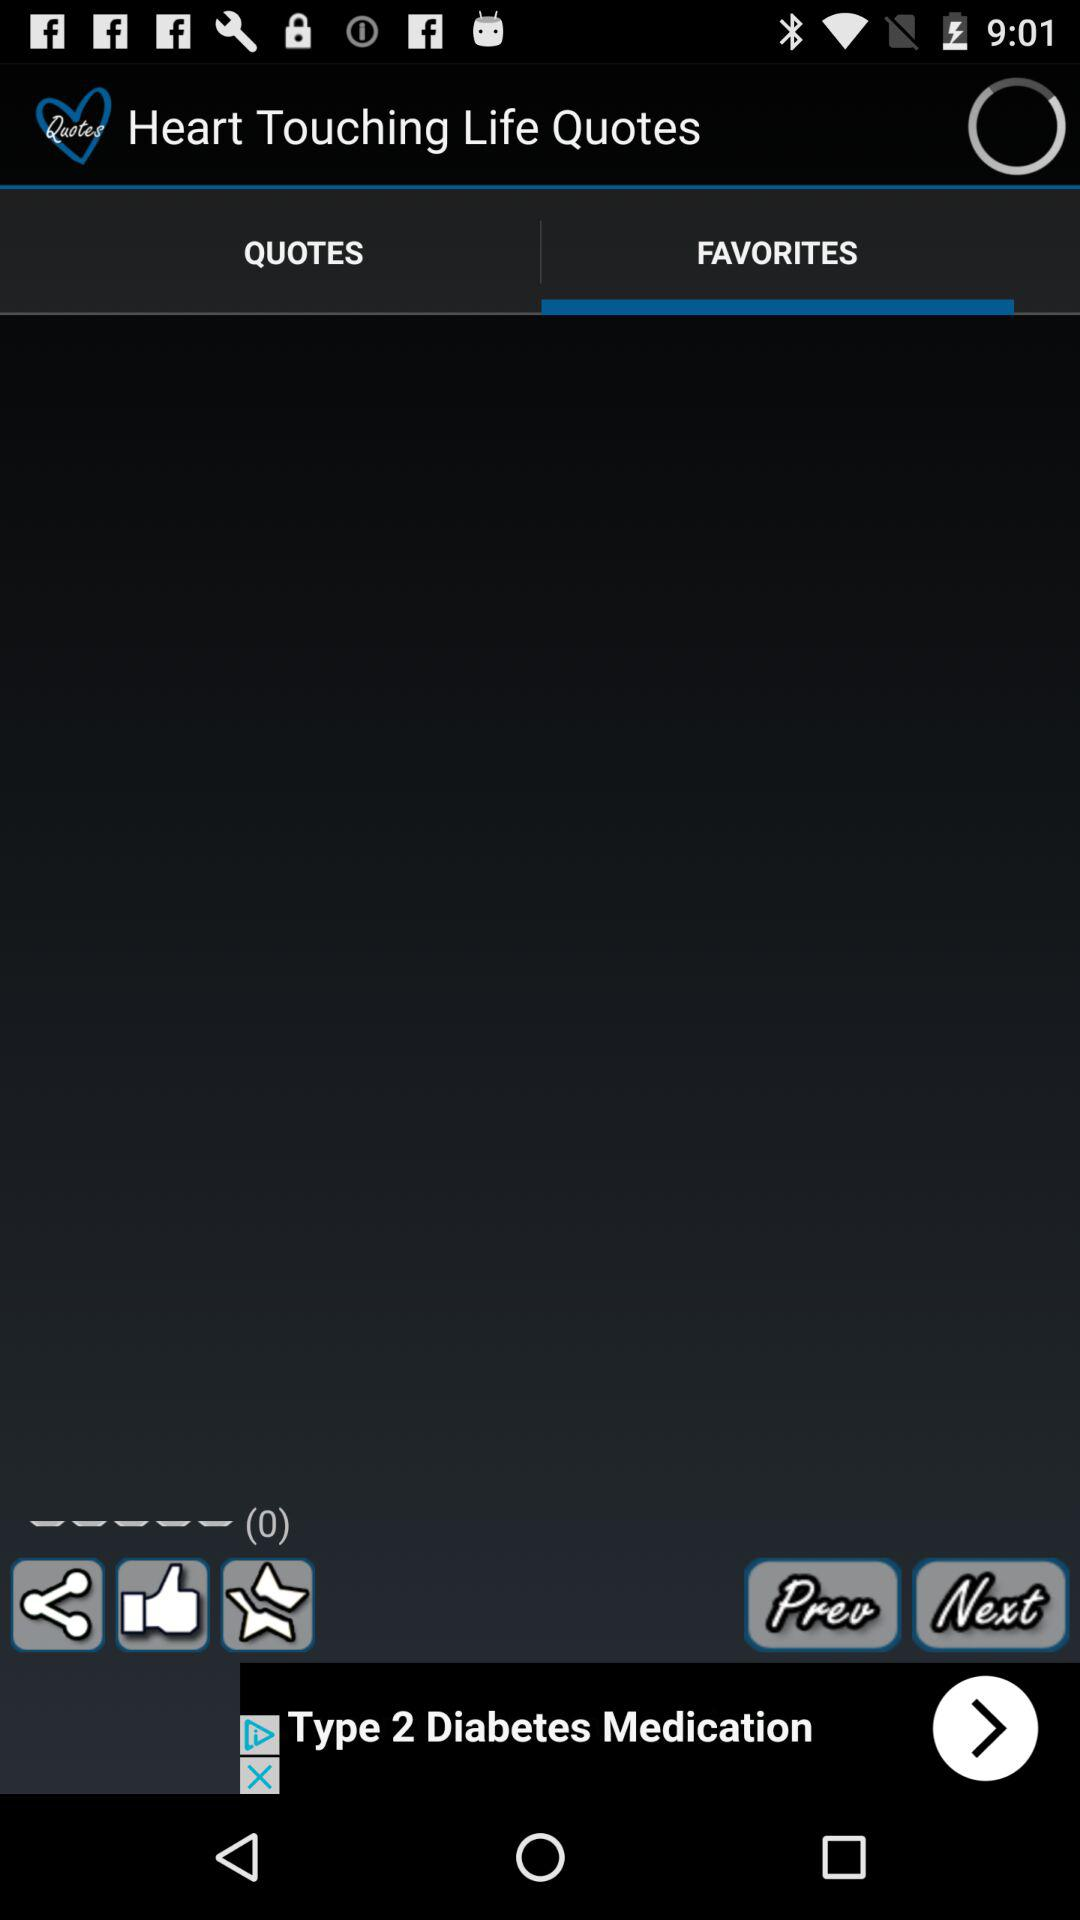Which tab is selected? The selected tab is "FAVORITES". 